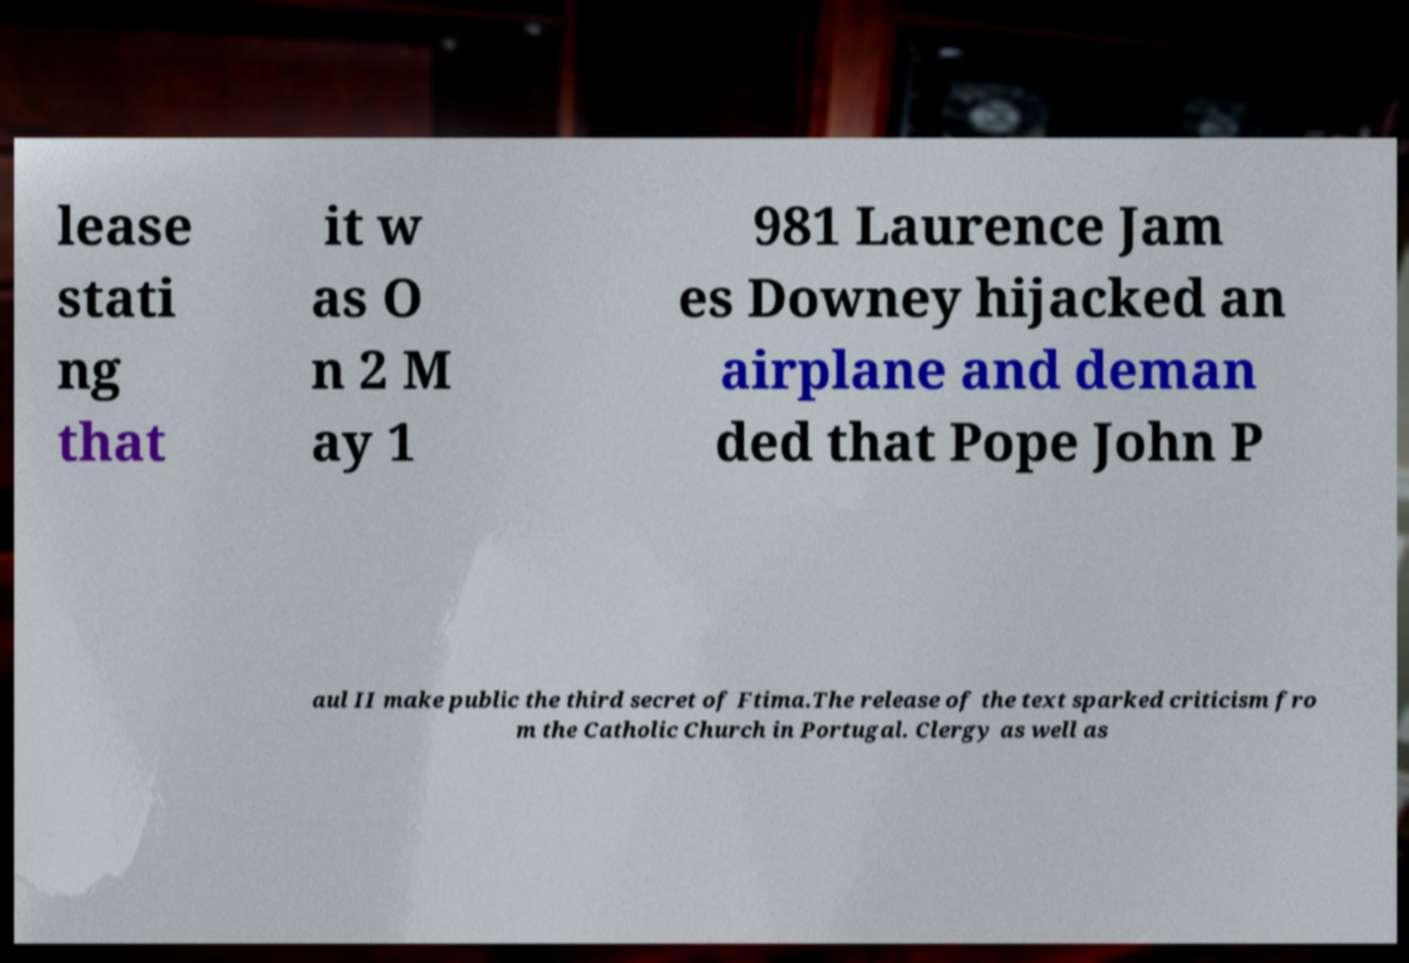Please identify and transcribe the text found in this image. lease stati ng that it w as O n 2 M ay 1 981 Laurence Jam es Downey hijacked an airplane and deman ded that Pope John P aul II make public the third secret of Ftima.The release of the text sparked criticism fro m the Catholic Church in Portugal. Clergy as well as 